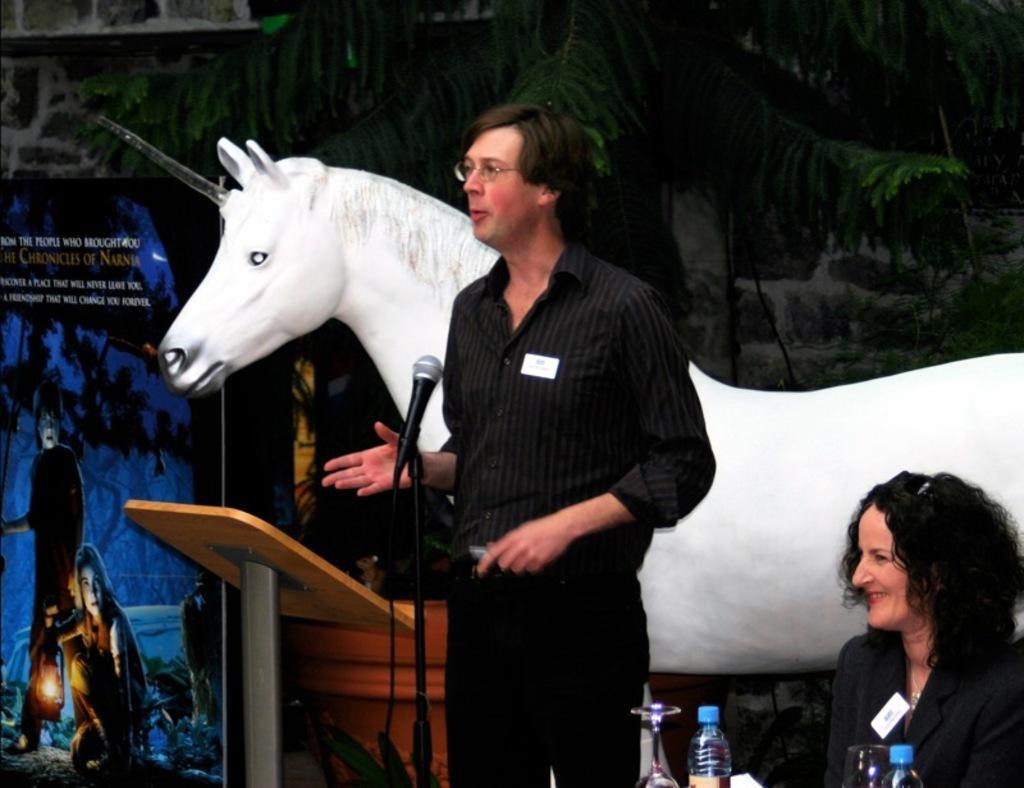Can you describe this image briefly? There is a person standing in the center in front a wooden desk and he is speaking on a microphone. Here we can see a woman on the right side and she is smiling. In the background we can see a horse statue and trees. 